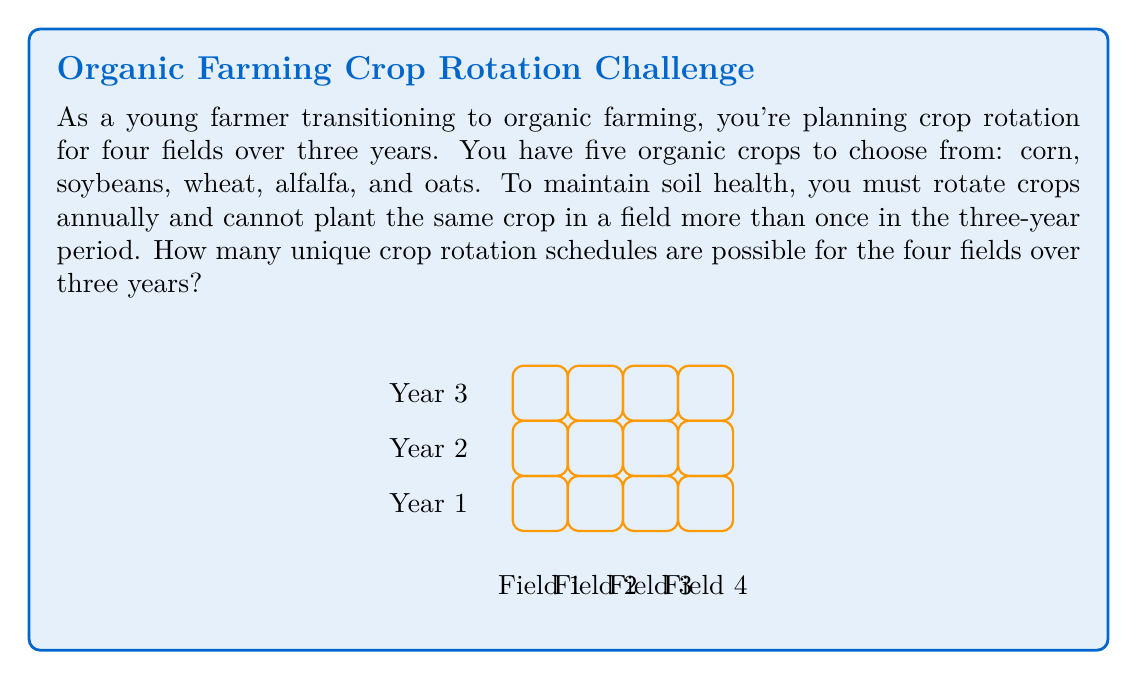Teach me how to tackle this problem. Let's approach this step-by-step:

1) For each field, we need to choose 3 different crops out of 5 for the 3 years.

2) This is a permutation problem. We're selecting 3 crops out of 5, where order matters (because the year matters), and repetition is not allowed.

3) For a single field, the number of possible crop rotations is given by the permutation formula:
   $$P(5,3) = \frac{5!}{(5-3)!} = \frac{5!}{2!} = 60$$

4) Now, we need to make this choice independently for each of the 4 fields.

5) According to the multiplication principle, when we have independent choices, we multiply the number of possibilities for each choice.

6) Therefore, the total number of unique crop rotation schedules for all 4 fields is:
   $$60^4 = 60 \times 60 \times 60 \times 60 = 12,960,000$$

Thus, there are 12,960,000 unique crop rotation schedules possible for the four fields over three years.
Answer: 12,960,000 